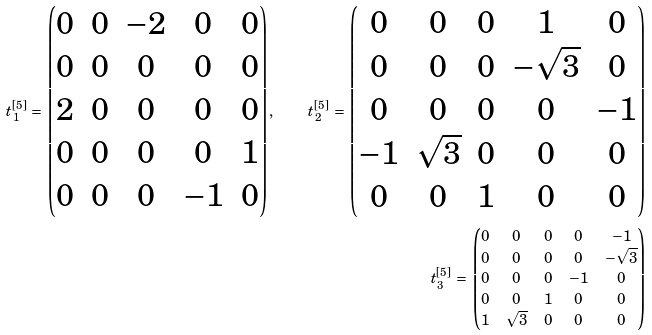<formula> <loc_0><loc_0><loc_500><loc_500>t _ { 1 } ^ { [ 5 ] } \, = \, \begin{pmatrix} 0 & 0 & - 2 & 0 & 0 \\ 0 & 0 & 0 & 0 & 0 \\ 2 & 0 & 0 & 0 & 0 \\ 0 & 0 & 0 & 0 & 1 \\ 0 & 0 & 0 & - 1 & 0 \end{pmatrix} , \quad t _ { 2 } ^ { [ 5 ] } \, = \, \begin{pmatrix} 0 & 0 & 0 & 1 & 0 \\ 0 & 0 & 0 & - \sqrt { 3 } & 0 \\ 0 & 0 & 0 & 0 & - 1 \\ - 1 & \sqrt { 3 } & 0 & 0 & 0 \\ 0 & 0 & 1 & 0 & 0 \end{pmatrix} \\ t _ { 3 } ^ { [ 5 ] } \, = \, \begin{pmatrix} 0 & 0 & 0 & 0 & - 1 \\ 0 & 0 & 0 & 0 & - \sqrt { 3 } \\ 0 & 0 & 0 & - 1 & 0 \\ 0 & 0 & 1 & 0 & 0 \\ 1 & \sqrt { 3 } & 0 & 0 & 0 \end{pmatrix}</formula> 